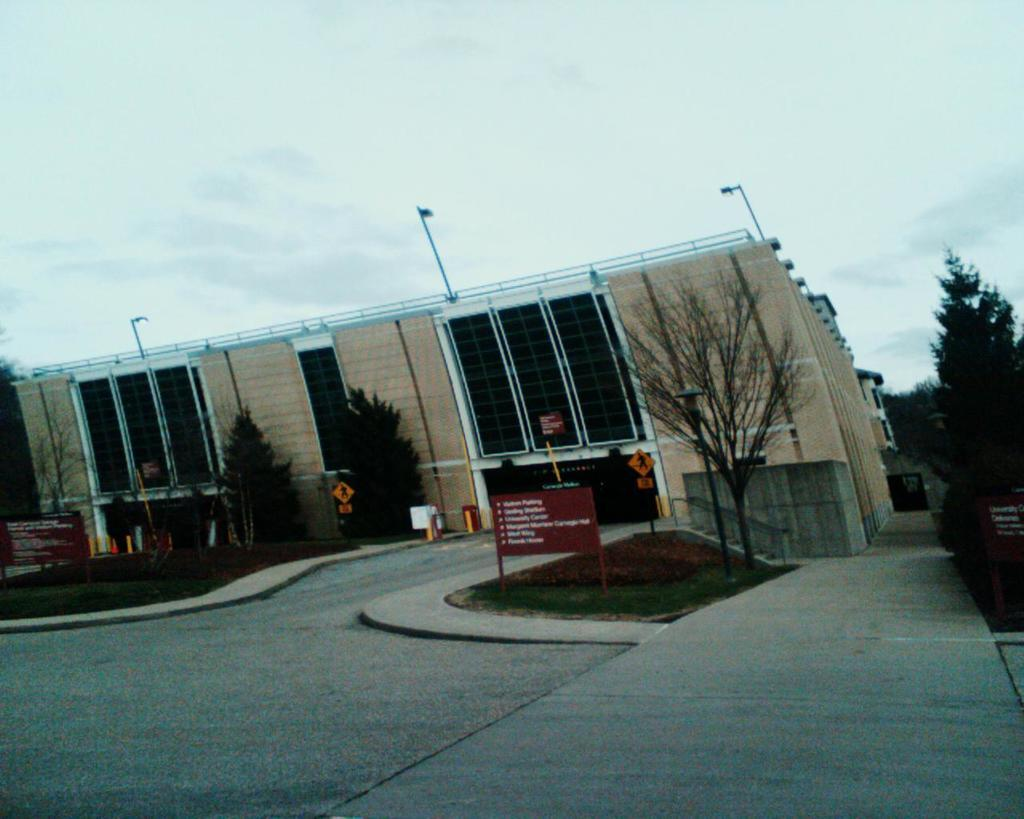What can be seen in the middle of the image? There are trees, poles, banners, and sign boards in the middle of the image. What is visible behind these objects? There is a building visible behind the trees, poles, banners, and sign boards. What can be seen in the sky at the top of the image? There are clouds in the sky at the top of the image. What type of iron is being used to make a decision in the image? There is no iron or decision-making process depicted in the image. Can you tell me how many eggnogs are being served in the image? There is no eggnog or any indication of food or drink in the image. 